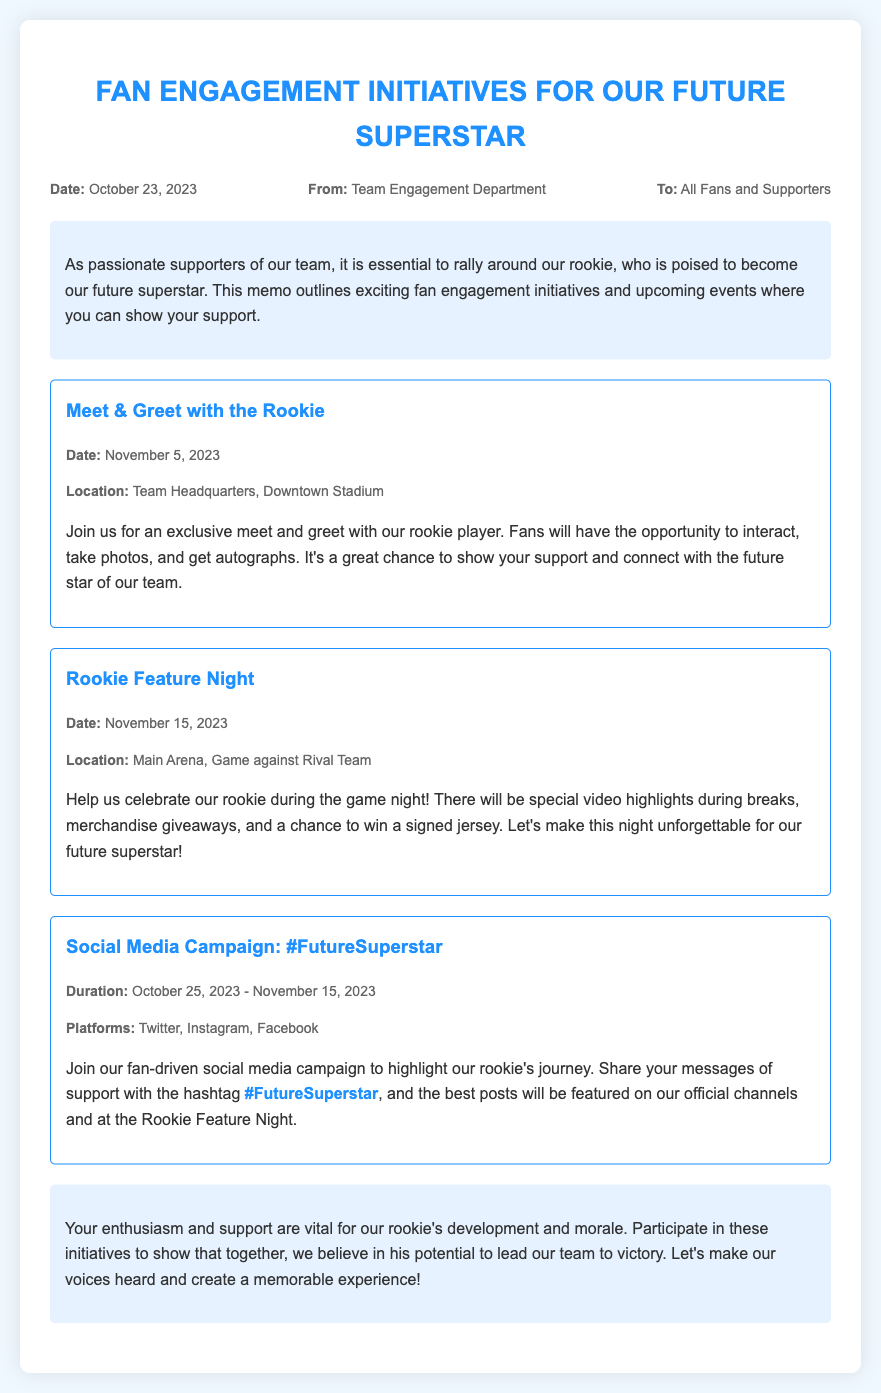what is the date of the Meet & Greet with the Rookie? The date for the Meet & Greet with the Rookie is explicitly stated in the document.
Answer: November 5, 2023 where will the Rookie Feature Night take place? The location of the Rookie Feature Night is provided in the details of the initiative.
Answer: Main Arena, Game against Rival Team what is the duration of the Social Media Campaign? The duration for the Social Media Campaign is specified in the document, including the start and end dates.
Answer: October 25, 2023 - November 15, 2023 what is the hashtag for the social media campaign? The document mentions a specific hashtag that fans should use for the campaign.
Answer: #FutureSuperstar how many initiatives are listed in the memo? The document provides a count of the distinct initiatives mentioned as part of the fan engagement initiatives.
Answer: Three why is it important to participate in these initiatives? The document highlights the significance of participation for the rookie's development and morale.
Answer: To show support for the rookie who sent the memo? The document states the department responsible for the communication.
Answer: Team Engagement Department 